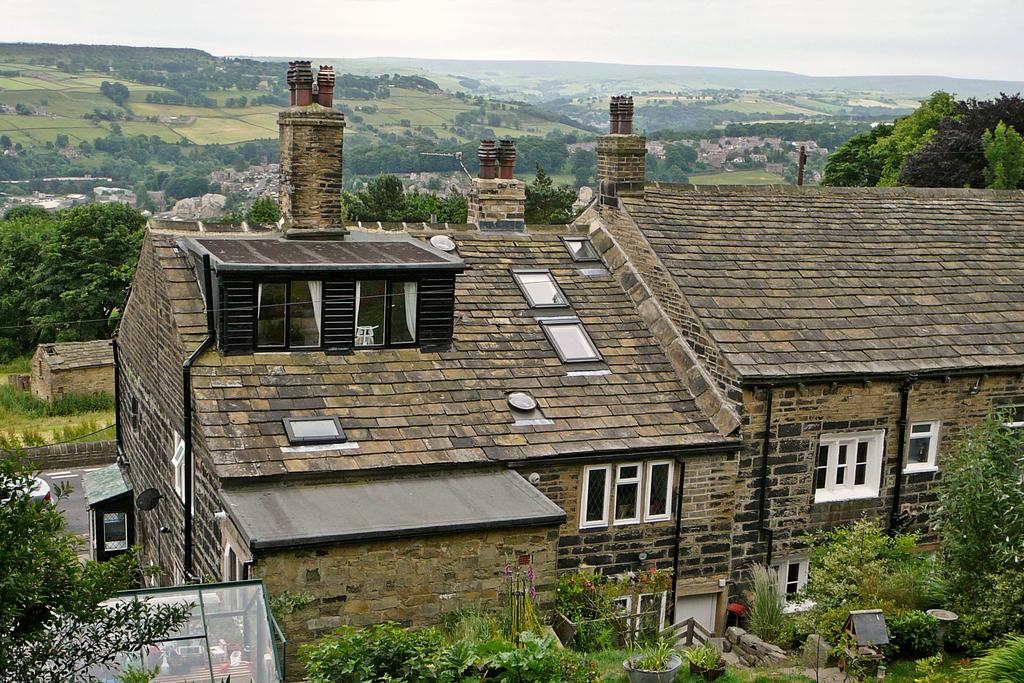What type of structure is present in the image? There is a building in the image. Can you describe the color of the building? The building is brown. What other natural elements can be seen in the image? There are trees and rocks in the image. What is the color of the trees? The trees are green. How would you describe the sky in the image? The sky is white in color. How many attempts does the mother make to climb the building in the image? There is no mother or attempt to climb the building in the image; it only shows a brown building, green trees, rocks, and a white sky. 